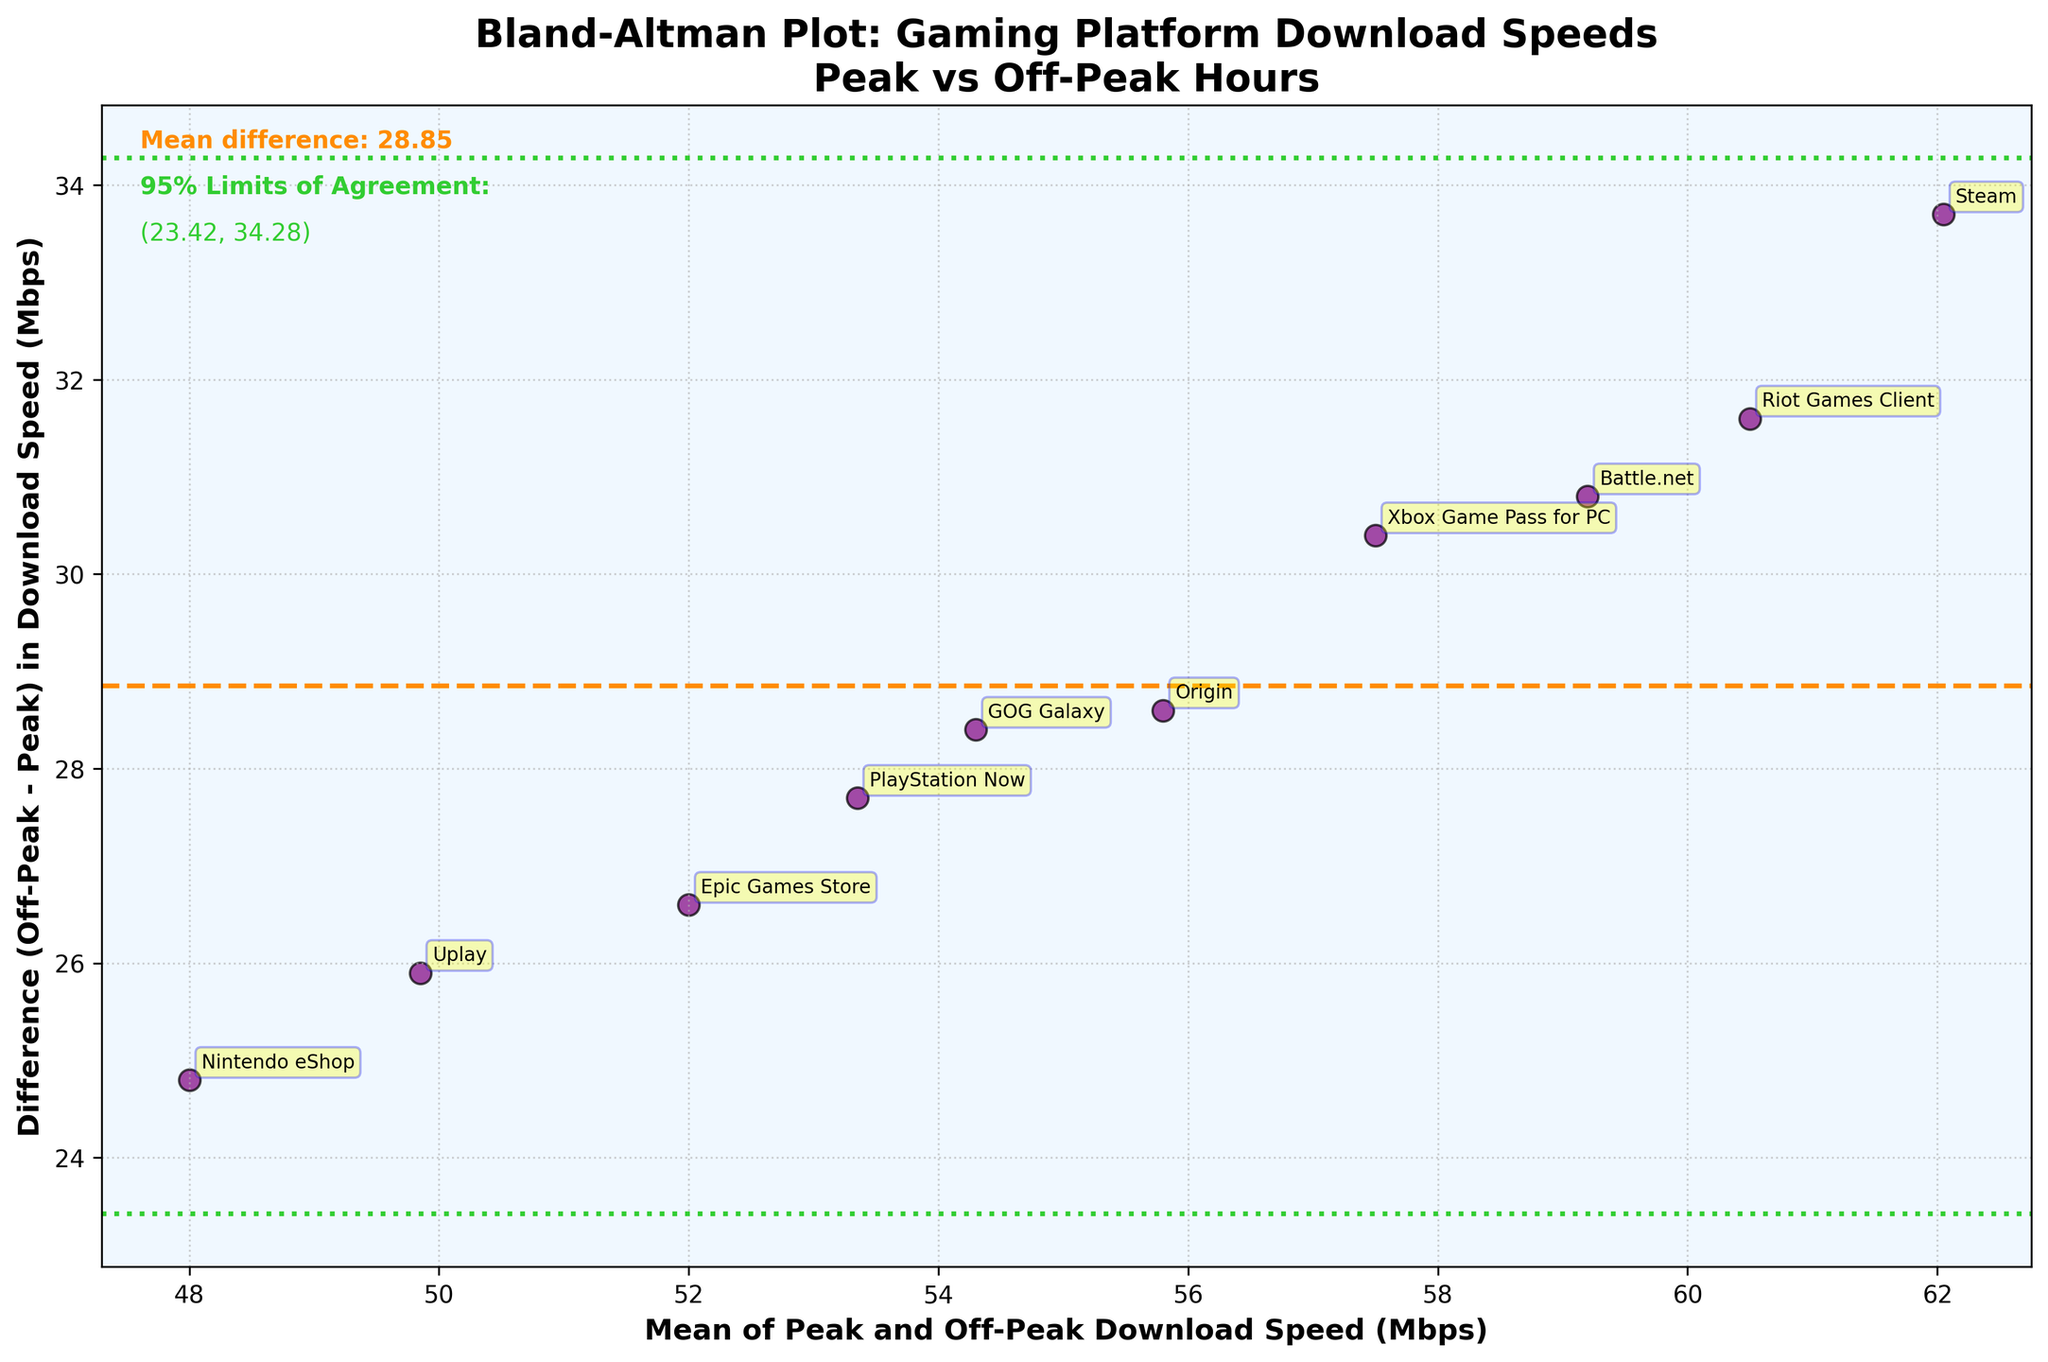What is the title of the figure? The title of the figure is located at the top in bold and large font.
Answer: Bland-Altman Plot: Gaming Platform Download Speeds Peak vs Off-Peak Hours What color represents the mean difference line? The mean difference line is represented by a distinct color that stands out between the data points.
Answer: Orange How many gaming platforms are included in the plot? Count the number of data points on the plot, where each point is indicated by a label with a game platform's name.
Answer: 10 What is the mean difference in download speeds? The mean difference is indicated as a text annotation on the plot, showing the numerical value of the mean difference.
Answer: 27.77 Mbps Which gaming platform had the highest mean download speed between peak and off-peak hours? Identify the platform with the highest x-coordinate value (mean of peak and off-peak speeds) on the plot.
Answer: Steam What is the difference in download speeds for the PlayStation Now service? Locate PlayStation Now on the plot and find the y-coordinate (difference in speeds) of its data point.
Answer: 27.7 Mbps Which platform shows the smallest difference in download speeds between peak and off-peak hours? Identify the platform with the smallest y-coordinate value (closest to zero or negative) on the plot.
Answer: Uplay What are the upper and lower limits of agreement in the plot? The limits of agreement are provided as horizontal lines on the plot with green annotations.
Answer: -4.34 Mbps and 59.88 Mbps How does the off-peak download speed of Epic Games Store compare with its peak download speed? Use the y-coordinate value of Epic Games Store to determine whether it is positive (off-peak > peak) or negative (off-peak < peak).
Answer: Off-peak is higher by 26.6 Mbps Which platforms have a difference in download speeds near the mean difference line? Identify platforms whose data points are closest to the horizontal orange line representing the mean difference.
Answer: Riot Games Client, GOG Galaxy 